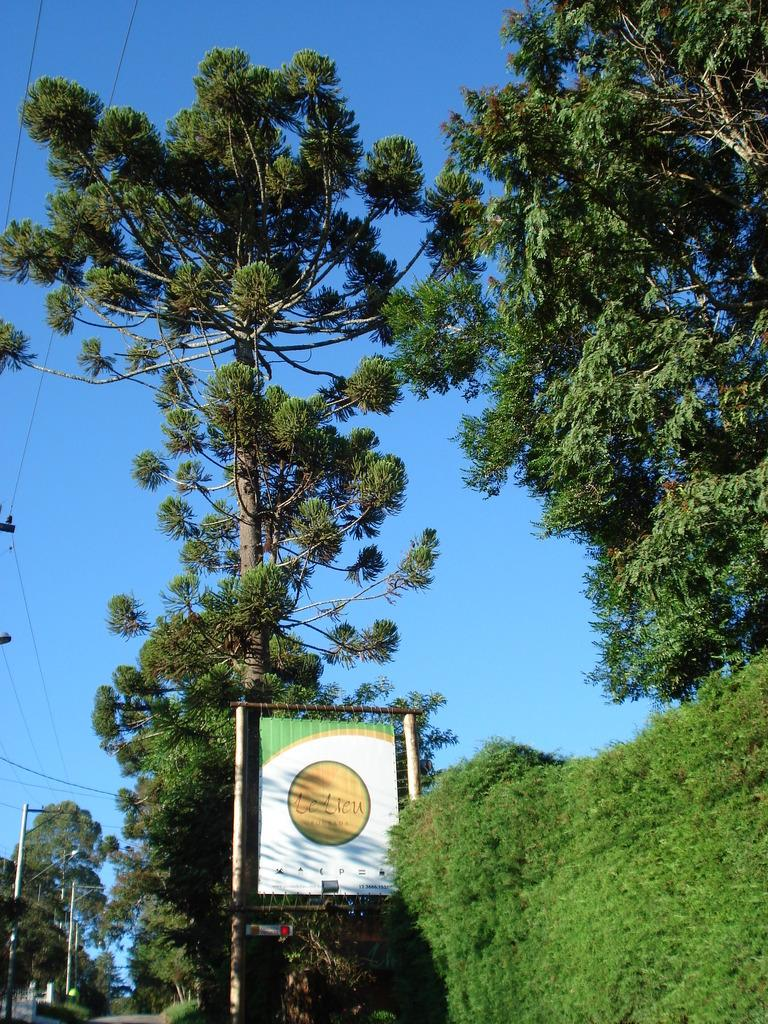What type of natural environment is depicted in the image? There are many trees in the image, indicating a forest or wooded area. What object is located in the front of the image? There is a board in the front of the image. What can be seen in the sky in the image? The sky is visible at the top of the image. How many dolls are sitting on the street in the image? There are no dolls or streets present in the image; it features trees and a board. 